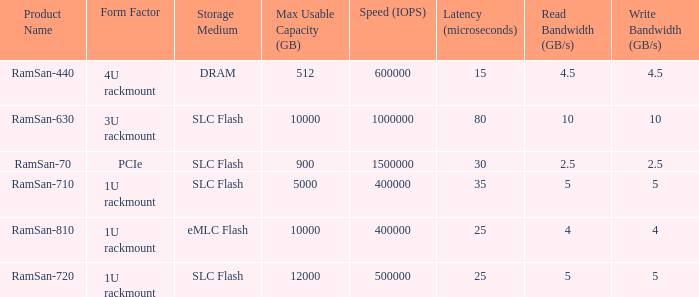What is the shape distortion for the range frequency of 10? 3U rackmount. Parse the table in full. {'header': ['Product Name', 'Form Factor', 'Storage Medium', 'Max Usable Capacity (GB)', 'Speed (IOPS)', 'Latency (microseconds)', 'Read Bandwidth (GB/s)', 'Write Bandwidth (GB/s)'], 'rows': [['RamSan-440', '4U rackmount', 'DRAM', '512', '600000', '15', '4.5', '4.5'], ['RamSan-630', '3U rackmount', 'SLC Flash', '10000', '1000000', '80', '10', '10'], ['RamSan-70', 'PCIe', 'SLC Flash', '900', '1500000', '30', '2.5', '2.5'], ['RamSan-710', '1U rackmount', 'SLC Flash', '5000', '400000', '35', '5', '5'], ['RamSan-810', '1U rackmount', 'eMLC Flash', '10000', '400000', '25', '4', '4'], ['RamSan-720', '1U rackmount', 'SLC Flash', '12000', '500000', '25', '5', '5']]} 